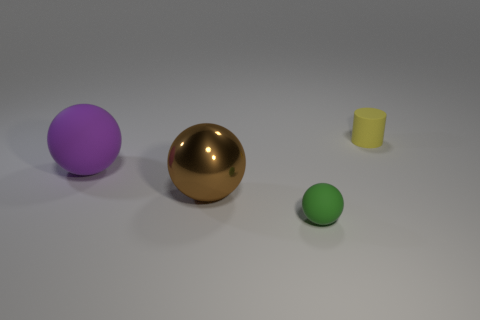Can you explain what each object in the image might symbolize if this was an abstract artwork? The golden sphere could symbolize wealth or value, the green sphere might represent growth or life, the yellow cylinder could signify stability or industriousness, and the purple sphere might stand for creativity or mystery. 